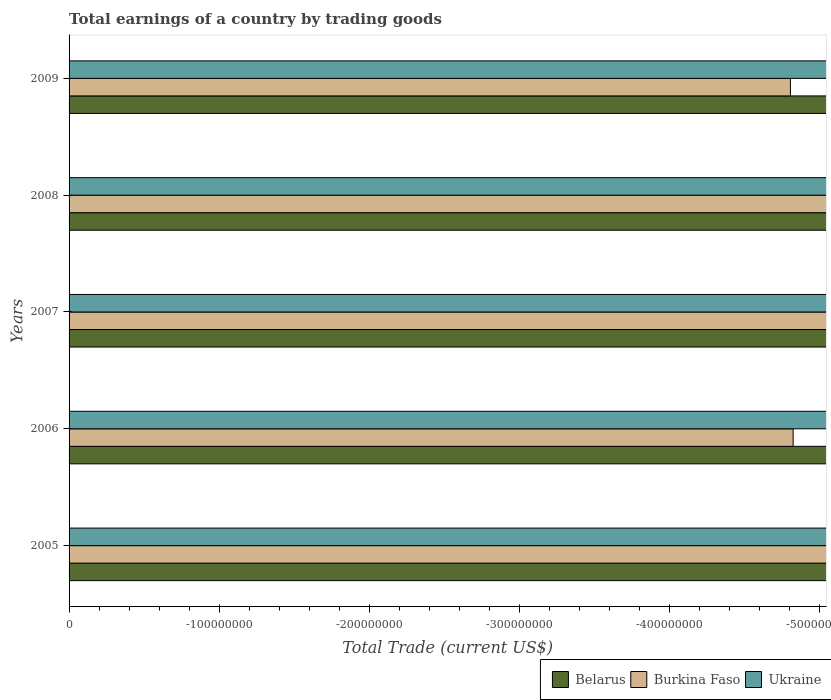How many different coloured bars are there?
Your answer should be very brief. 0. Are the number of bars per tick equal to the number of legend labels?
Ensure brevity in your answer.  No. Are the number of bars on each tick of the Y-axis equal?
Give a very brief answer. Yes. What is the label of the 3rd group of bars from the top?
Your response must be concise. 2007. What is the total earnings in Ukraine in 2006?
Make the answer very short. 0. In how many years, is the total earnings in Burkina Faso greater than -460000000 US$?
Offer a very short reply. 0. In how many years, is the total earnings in Ukraine greater than the average total earnings in Ukraine taken over all years?
Keep it short and to the point. 0. Is it the case that in every year, the sum of the total earnings in Ukraine and total earnings in Belarus is greater than the total earnings in Burkina Faso?
Offer a terse response. No. Does the graph contain any zero values?
Provide a short and direct response. Yes. How many legend labels are there?
Your answer should be compact. 3. What is the title of the graph?
Provide a succinct answer. Total earnings of a country by trading goods. What is the label or title of the X-axis?
Provide a succinct answer. Total Trade (current US$). What is the label or title of the Y-axis?
Make the answer very short. Years. What is the Total Trade (current US$) in Belarus in 2007?
Provide a short and direct response. 0. What is the Total Trade (current US$) of Burkina Faso in 2007?
Give a very brief answer. 0. What is the Total Trade (current US$) of Belarus in 2009?
Make the answer very short. 0. What is the Total Trade (current US$) of Burkina Faso in 2009?
Provide a succinct answer. 0. What is the Total Trade (current US$) in Ukraine in 2009?
Keep it short and to the point. 0. What is the total Total Trade (current US$) of Burkina Faso in the graph?
Your answer should be compact. 0. What is the average Total Trade (current US$) in Belarus per year?
Provide a succinct answer. 0. What is the average Total Trade (current US$) of Burkina Faso per year?
Provide a succinct answer. 0. What is the average Total Trade (current US$) of Ukraine per year?
Your answer should be compact. 0. 